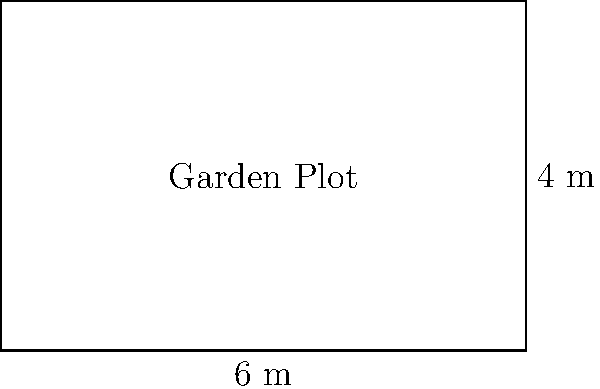A local community garden has assigned you a rectangular plot. The plot measures 6 meters in length and 4 meters in width. To properly fence your garden, you need to calculate its perimeter. What is the perimeter of your rectangular garden plot in meters? Let's calculate the perimeter step-by-step:

1. Recall the formula for the perimeter of a rectangle:
   $$ \text{Perimeter} = 2 \times (\text{length} + \text{width}) $$

2. We know:
   - Length = 6 meters
   - Width = 4 meters

3. Let's substitute these values into the formula:
   $$ \text{Perimeter} = 2 \times (6 \text{ m} + 4 \text{ m}) $$

4. First, add the length and width:
   $$ \text{Perimeter} = 2 \times (10 \text{ m}) $$

5. Now, multiply by 2:
   $$ \text{Perimeter} = 20 \text{ m} $$

Therefore, the perimeter of your rectangular garden plot is 20 meters.
Answer: 20 m 